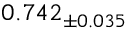Convert formula to latex. <formula><loc_0><loc_0><loc_500><loc_500>0 . 7 4 2 _ { \pm 0 . 0 3 5 }</formula> 